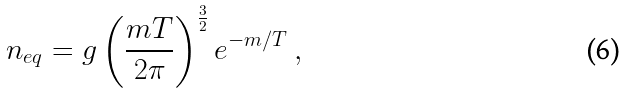<formula> <loc_0><loc_0><loc_500><loc_500>n _ { e q } = g \left ( \frac { m T } { 2 \pi } \right ) ^ { \frac { 3 } { 2 } } e ^ { - m / T } \ ,</formula> 